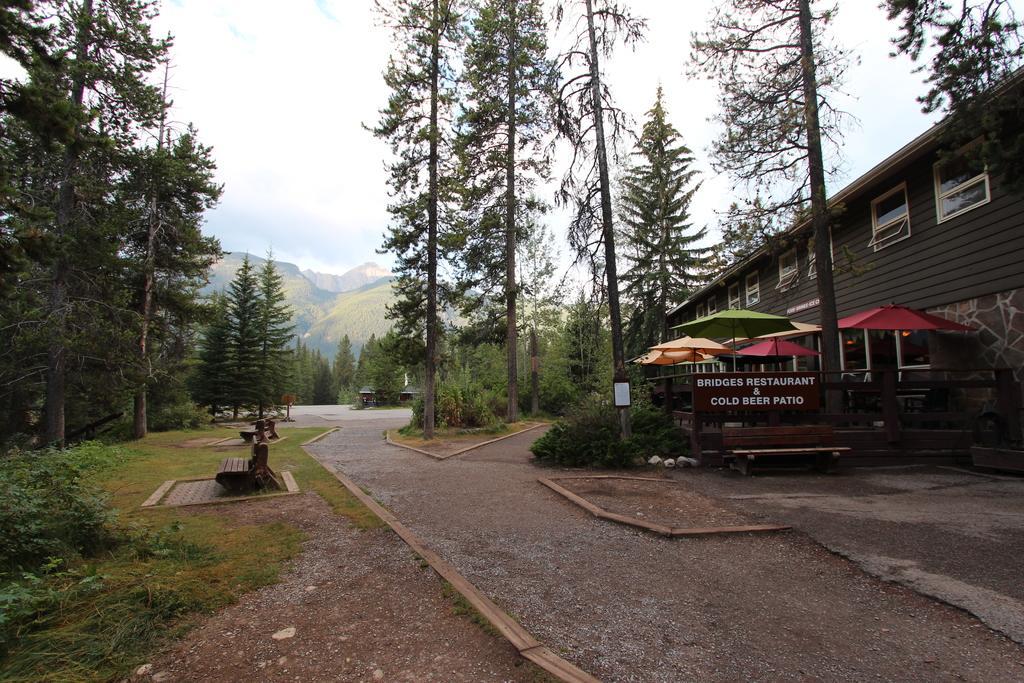Can you describe this image briefly? In this image we can see building with windows, trees, plants, mountains, wooden benches, board with some text and we can also see the sky. 